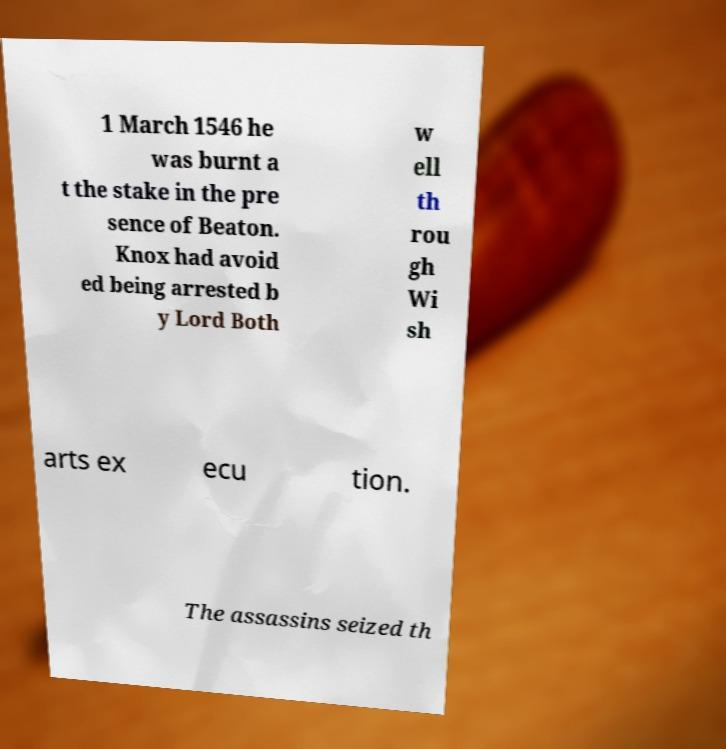What messages or text are displayed in this image? I need them in a readable, typed format. 1 March 1546 he was burnt a t the stake in the pre sence of Beaton. Knox had avoid ed being arrested b y Lord Both w ell th rou gh Wi sh arts ex ecu tion. The assassins seized th 